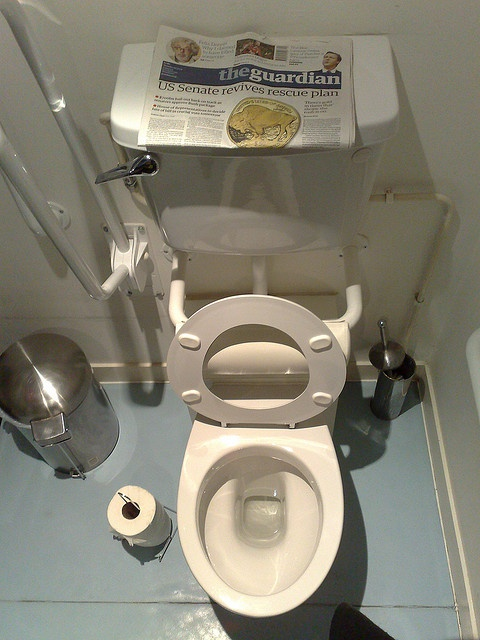Describe the objects in this image and their specific colors. I can see a toilet in gray, beige, darkgray, and tan tones in this image. 